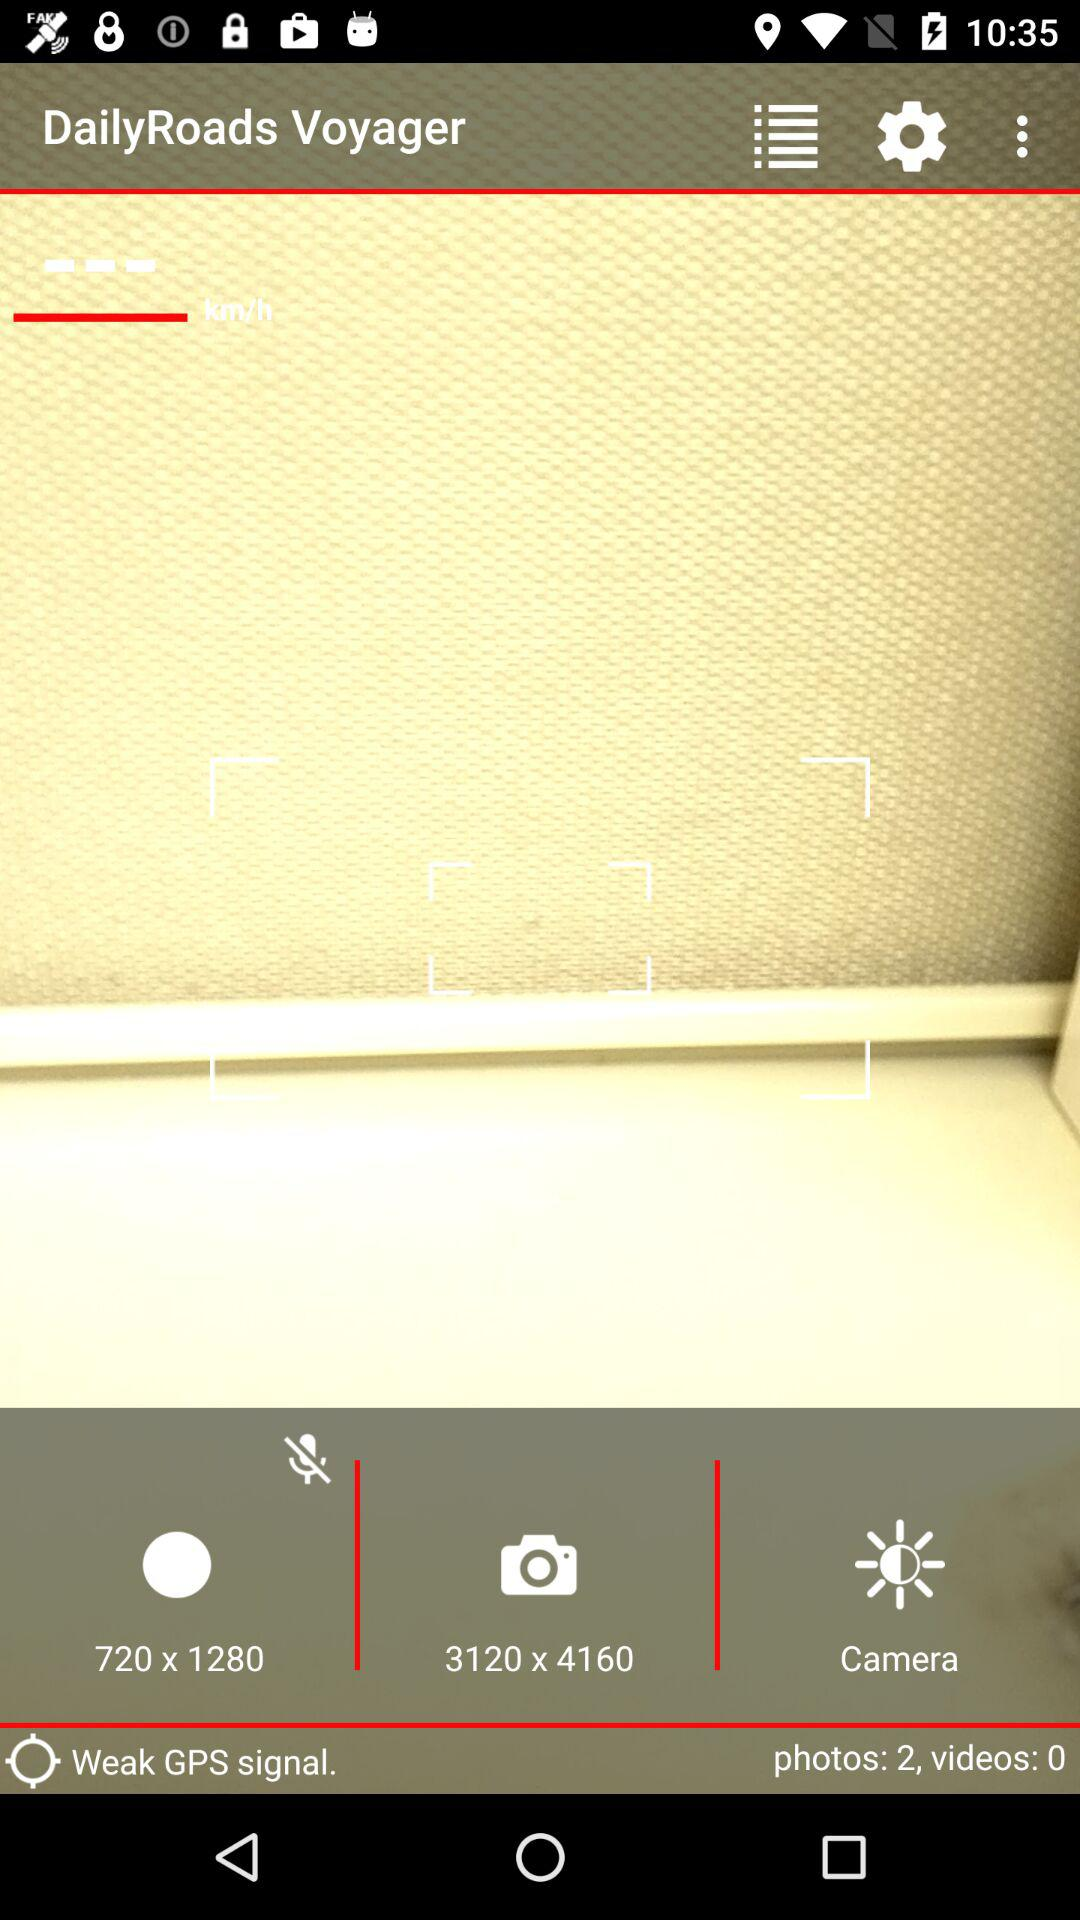What is the size of the photos? The size of the photos is 3120 × 4160. 